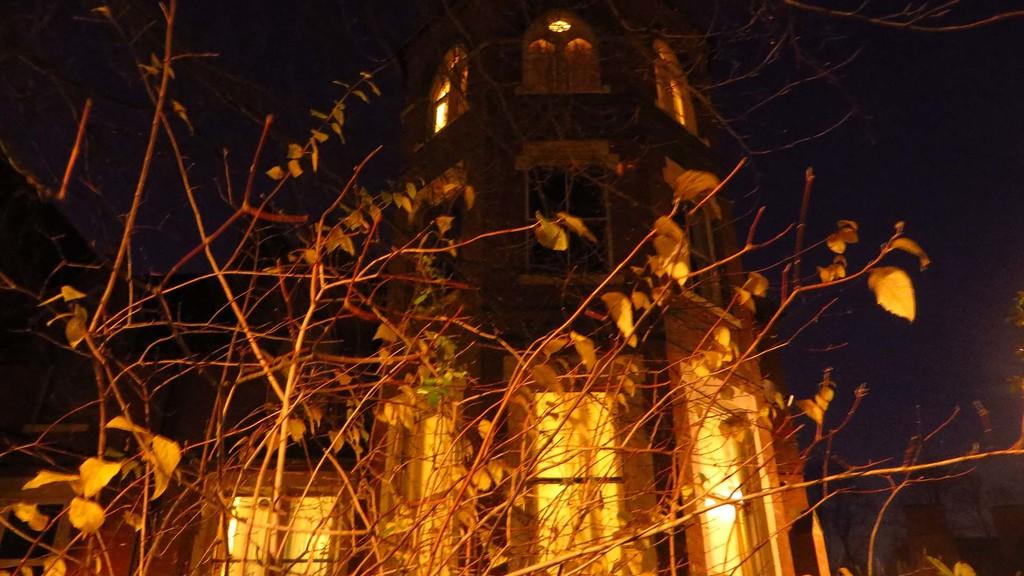What type of structure is present in the image? There is a building in the image. What can be seen illuminated in the image? There are lights visible in the image. What type of natural vegetation is present in the image? There are trees in the image. What type of leaf can be seen falling from the tree in the image? There is no leaf visible in the image, nor is there any indication of a leaf falling from a tree. 